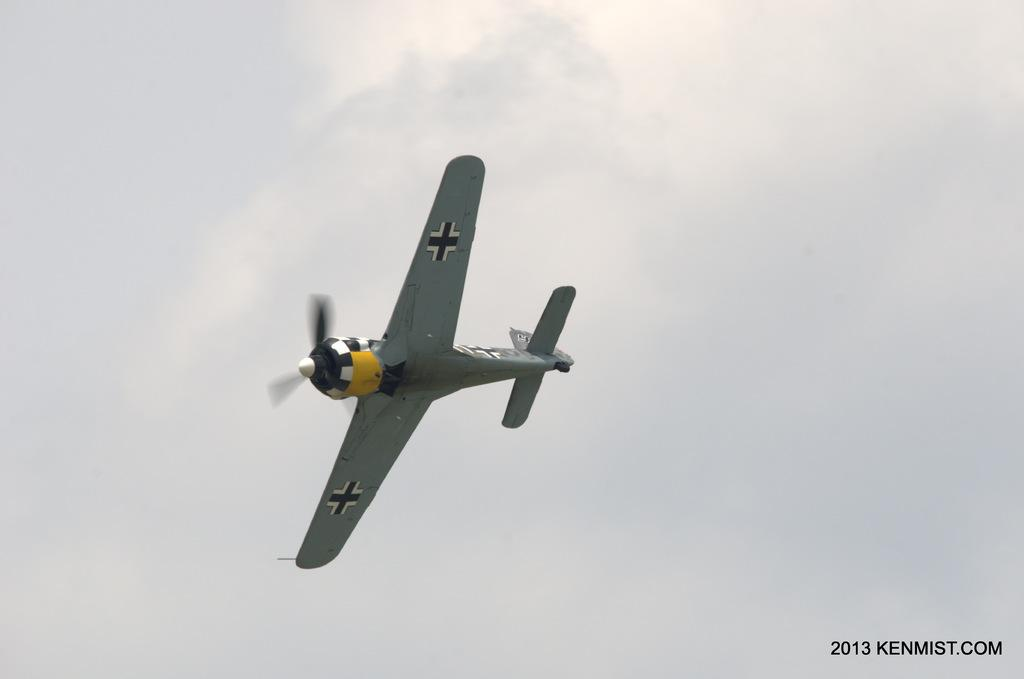What is the main subject of the image? The main subject of the image is an aeroplane. What is the aeroplane doing in the image? The aeroplane is flying in the air. What color is the aeroplane? The aeroplane is grey in color. How would you describe the sky in the image? The sky is cloudy. Where is the truck carrying sticks to the playground in the image? There is no truck, sticks, or playground present in the image. 